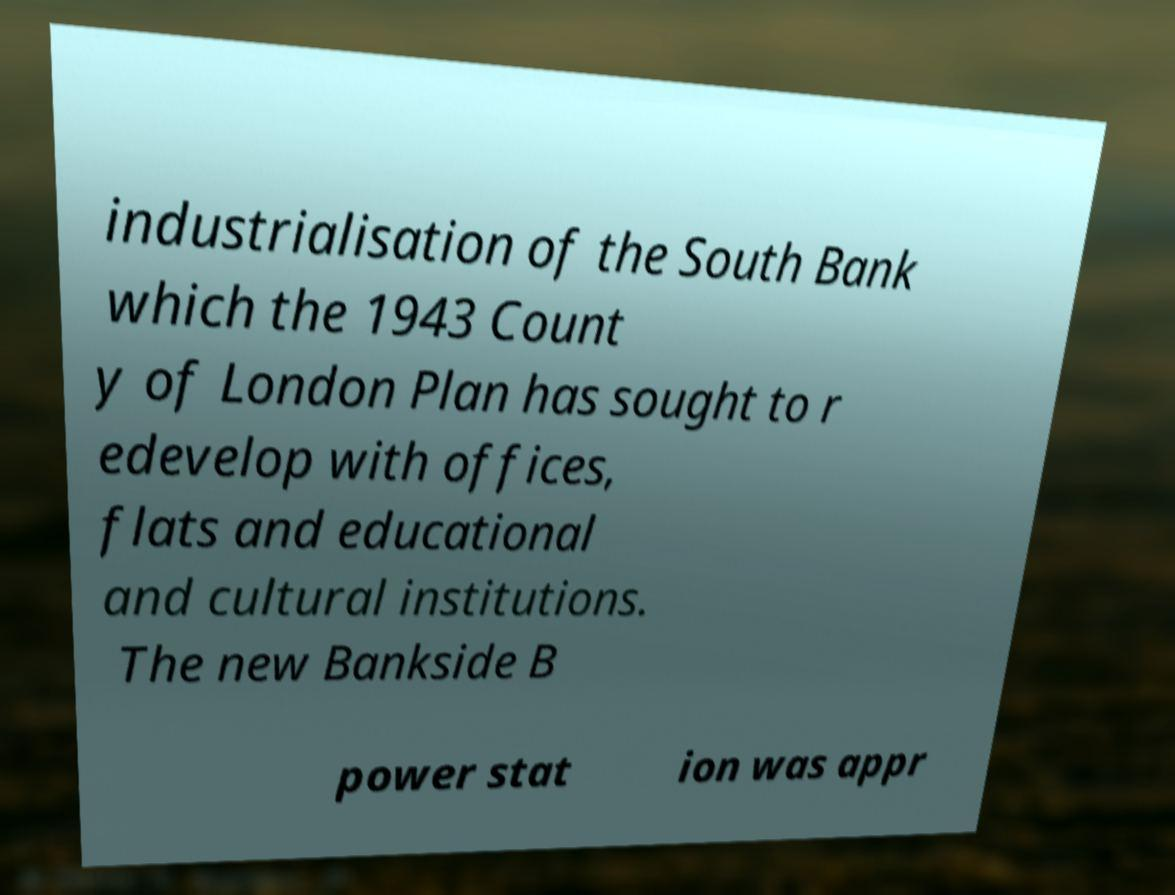Can you accurately transcribe the text from the provided image for me? industrialisation of the South Bank which the 1943 Count y of London Plan has sought to r edevelop with offices, flats and educational and cultural institutions. The new Bankside B power stat ion was appr 